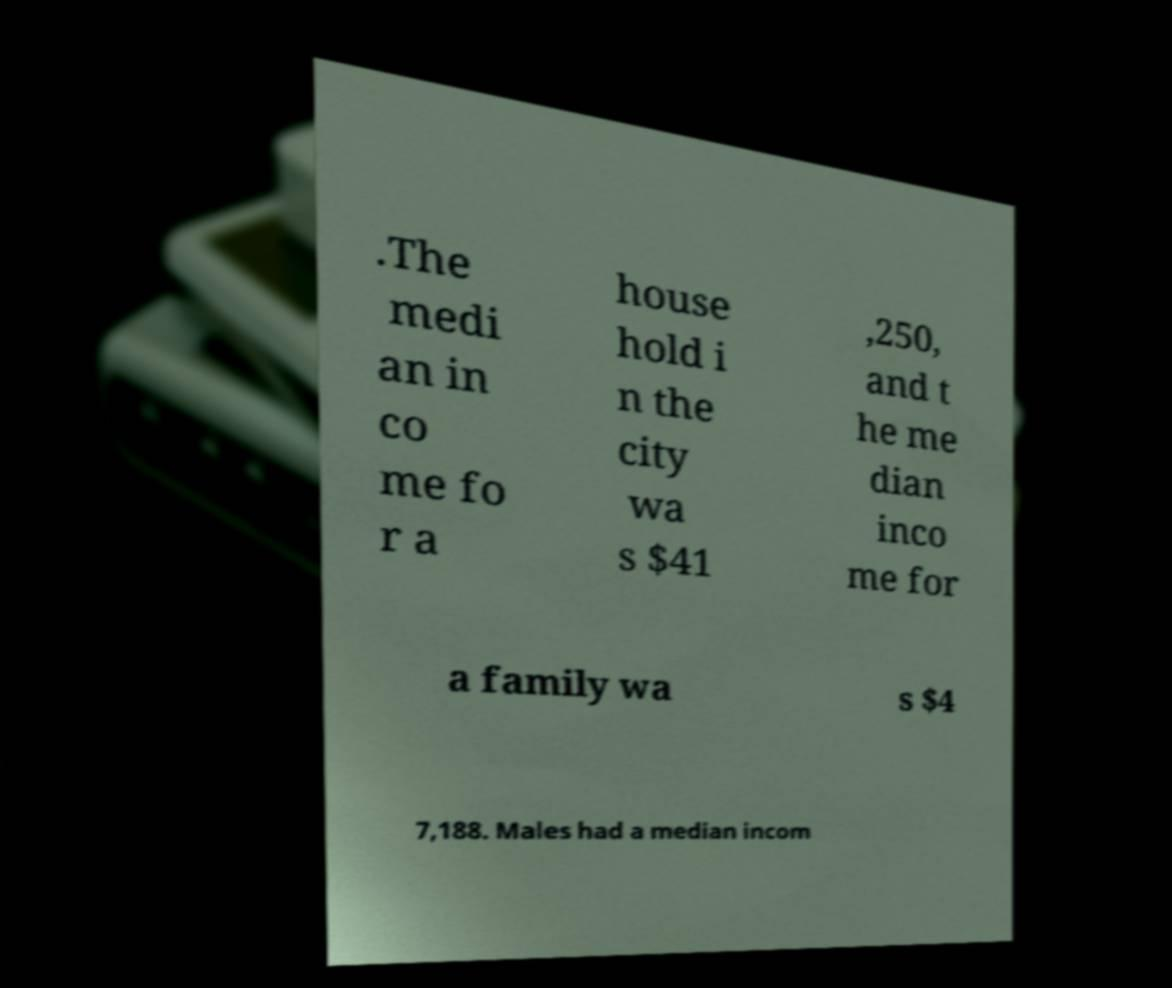I need the written content from this picture converted into text. Can you do that? .The medi an in co me fo r a house hold i n the city wa s $41 ,250, and t he me dian inco me for a family wa s $4 7,188. Males had a median incom 